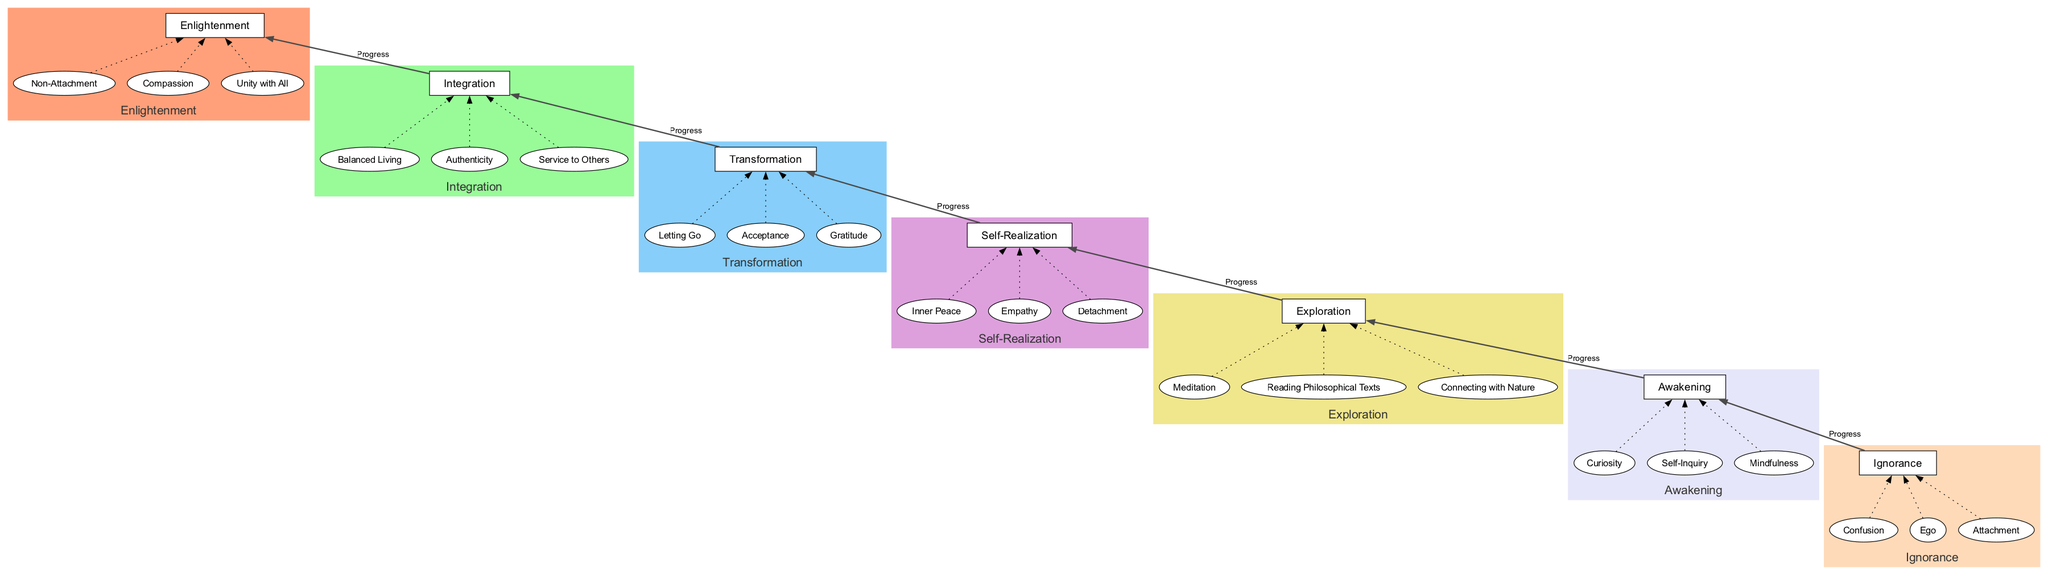What is the first stage in the journey? The diagram lists "Ignorance" as the first stage when viewed from the bottom to the top, indicating it as the starting point of the journey.
Answer: Ignorance How many elements are associated with the "Awakening" stage? By examining the "Awakening" stage in the diagram, we can see that it includes three elements: "Curiosity," "Self-Inquiry," and "Mindfulness."
Answer: 3 Which stage follows "Self-Realization"? The flow of the diagram shows that "Transformation" directly follows the "Self-Realization" stage, indicating the next step in the journey.
Answer: Transformation What is the last stage of the journey? The last stage displayed at the top of the diagram is "Enlightenment," signaling it as the ultimate goal of the journey of self-discovery.
Answer: Enlightenment What element connects to "Integration"? In the diagram, the element "Service to Others" connects directly to the "Integration" stage, illustrating one aspect of incorporating new wisdom into life.
Answer: Service to Others Which two stages are connected by the label "Progress"? The diagram indicates that "Transformation" and "Integration" are connected by the label "Progress," showing the flow from one stage to the next.
Answer: Transformation and Integration What is the description of the "Exploration" stage? The description seen in the diagram for "Exploration" states that it involves actively seeking knowledge and experiences for better understanding of self and world.
Answer: Actively seeking knowledge and experiences to understand the self and the world better How many total stages are represented in the diagram? There are seven stages listed in the diagram, each representing a different phase in the journey of self-discovery.
Answer: 7 Which element appears in the "Ignorance" stage? The element "Confusion" appears in the "Ignorance" stage, signifying one of the characteristics of that state.
Answer: Confusion Which stage emphasizes "Non-Attachment"? The diagram highlights "Enlightenment" as the stage that emphasizes "Non-Attachment," reflecting a core concept in achieving this state.
Answer: Enlightenment 